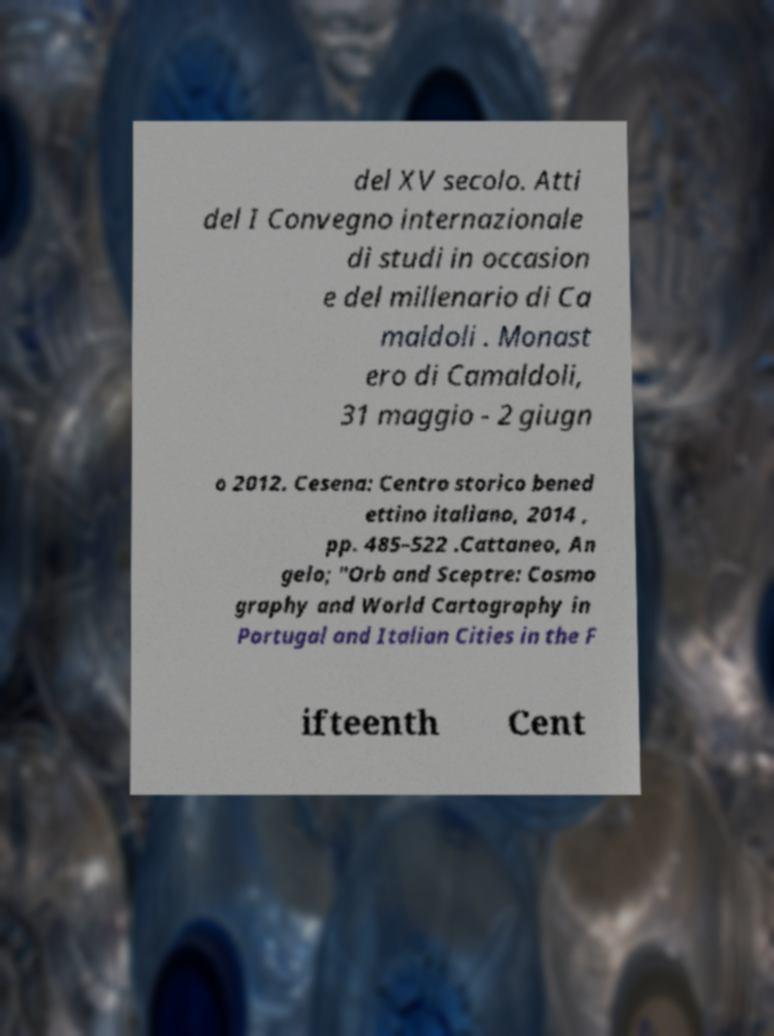I need the written content from this picture converted into text. Can you do that? del XV secolo. Atti del I Convegno internazionale di studi in occasion e del millenario di Ca maldoli . Monast ero di Camaldoli, 31 maggio - 2 giugn o 2012. Cesena: Centro storico bened ettino italiano, 2014 , pp. 485–522 .Cattaneo, An gelo; "Orb and Sceptre: Cosmo graphy and World Cartography in Portugal and Italian Cities in the F ifteenth Cent 